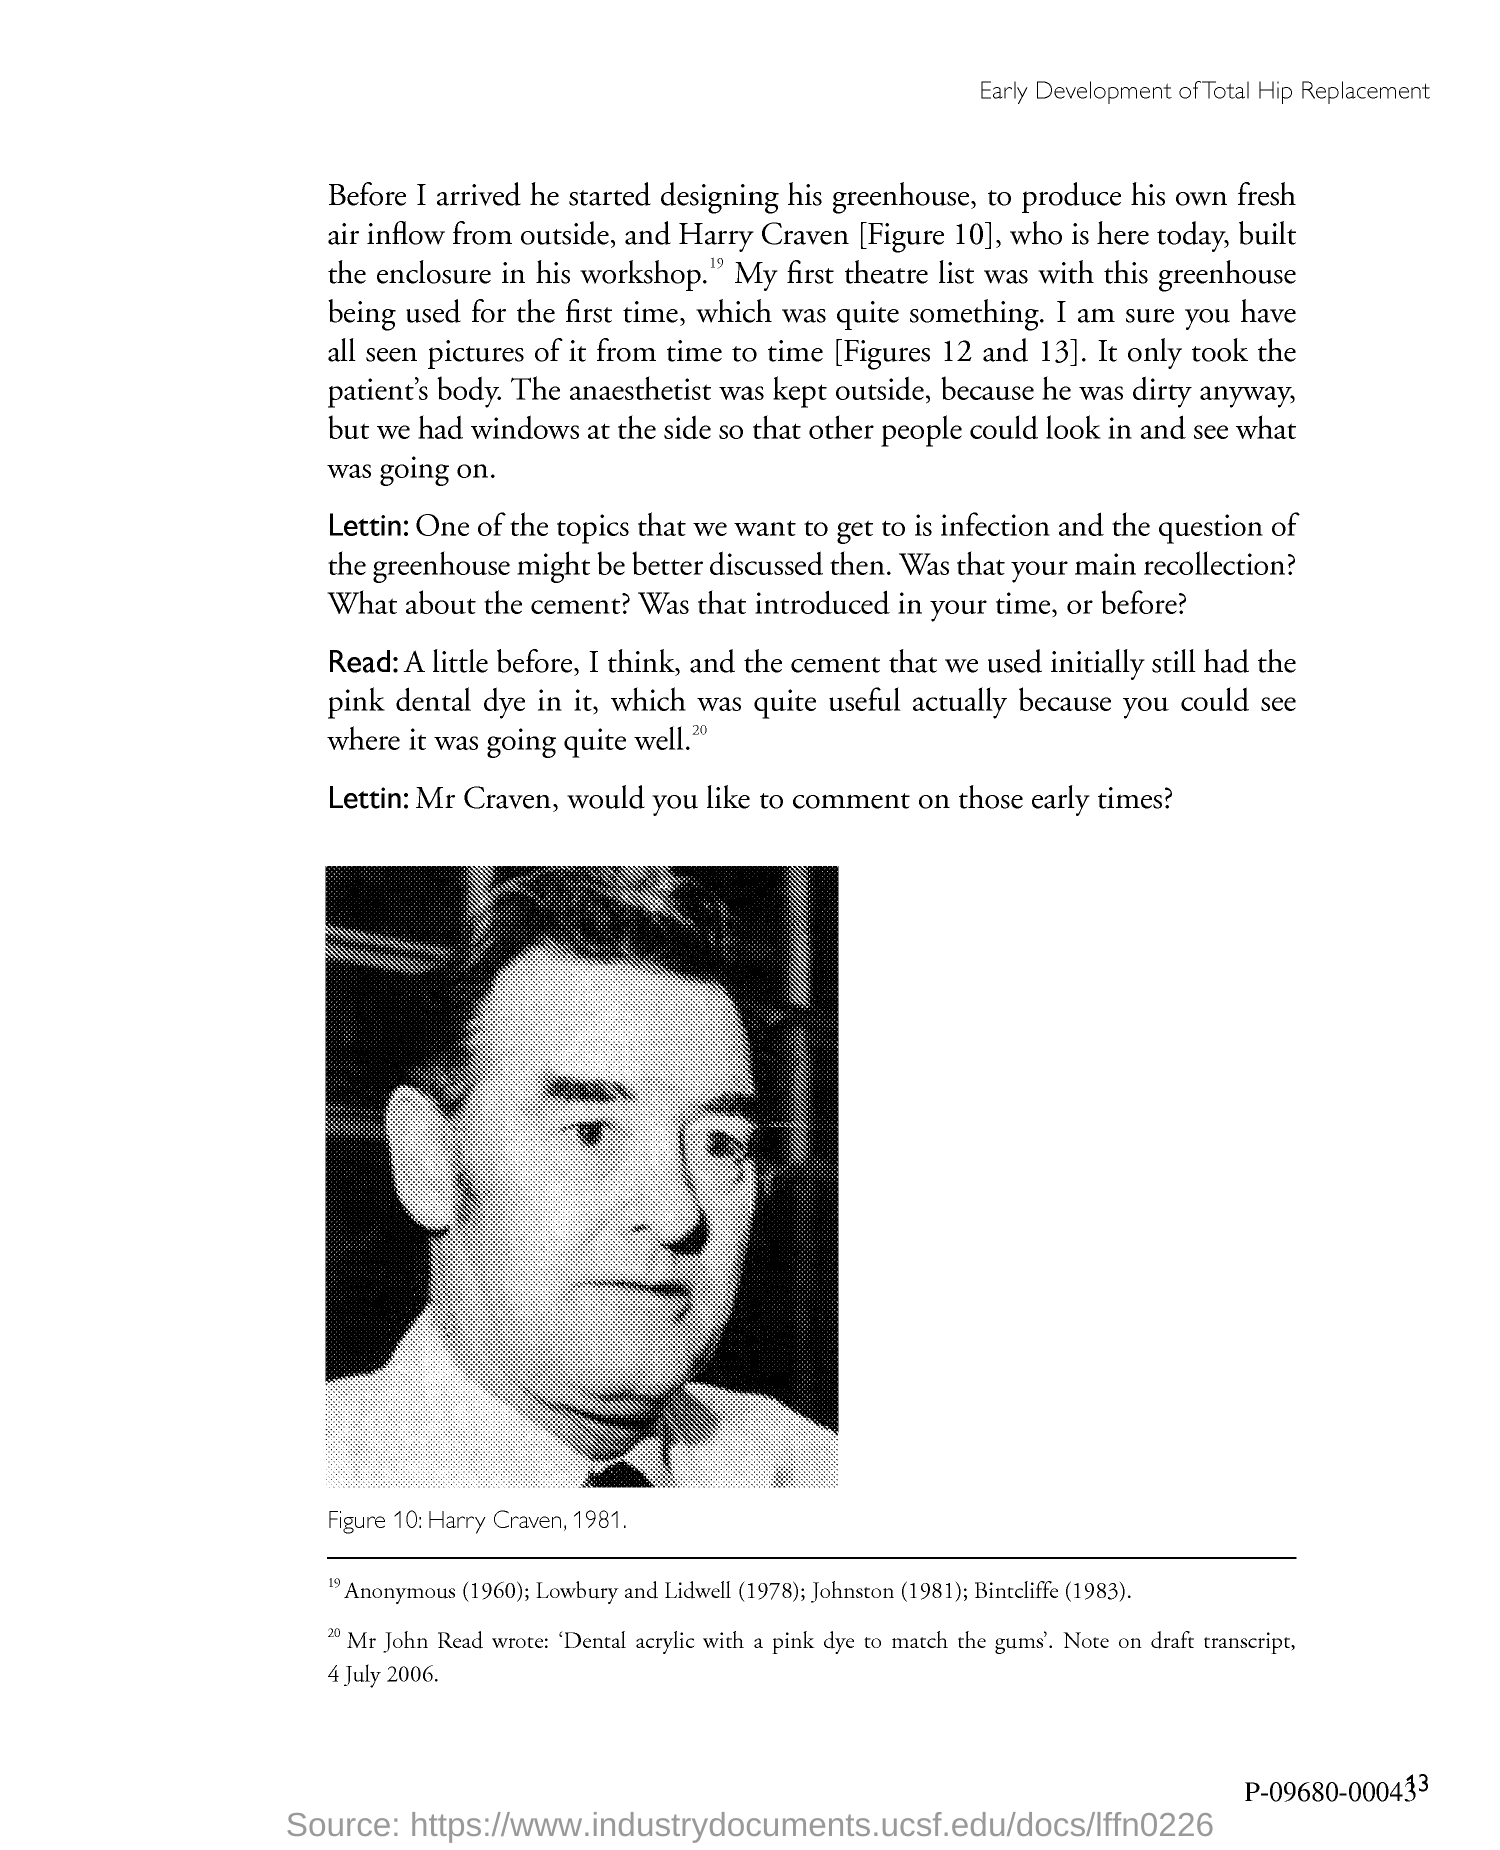Draw attention to some important aspects in this diagram. The page number is 13, as declared. The person depicted in the image is named Harry Craven. 